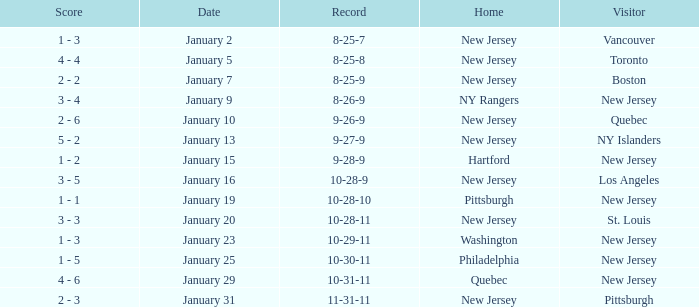What was the home team when the visiting team was Toronto? New Jersey. 